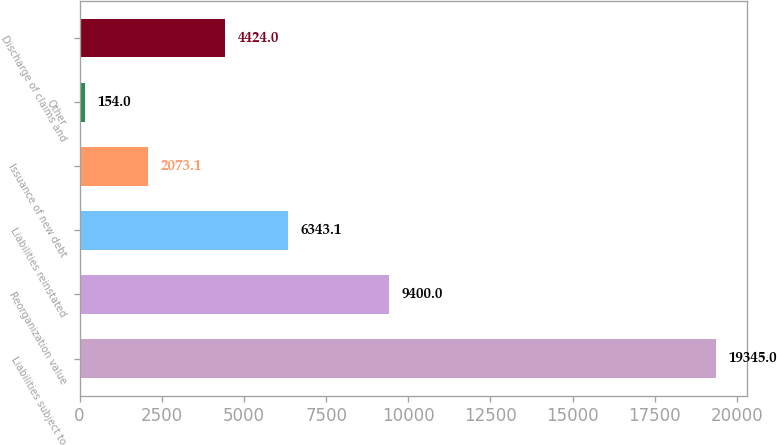Convert chart. <chart><loc_0><loc_0><loc_500><loc_500><bar_chart><fcel>Liabilities subject to<fcel>Reorganization value<fcel>Liabilities reinstated<fcel>Issuance of new debt<fcel>Other<fcel>Discharge of claims and<nl><fcel>19345<fcel>9400<fcel>6343.1<fcel>2073.1<fcel>154<fcel>4424<nl></chart> 